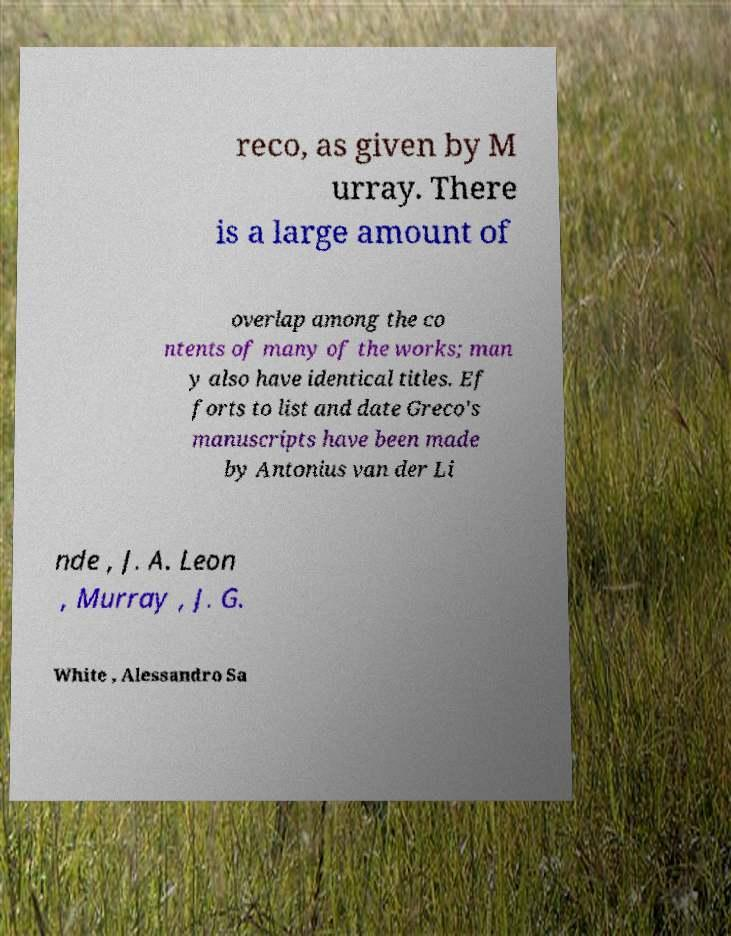Please identify and transcribe the text found in this image. reco, as given by M urray. There is a large amount of overlap among the co ntents of many of the works; man y also have identical titles. Ef forts to list and date Greco's manuscripts have been made by Antonius van der Li nde , J. A. Leon , Murray , J. G. White , Alessandro Sa 